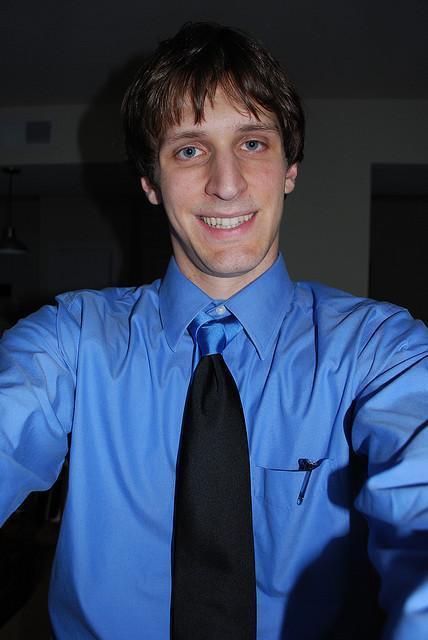How many food poles for the giraffes are there?
Give a very brief answer. 0. 